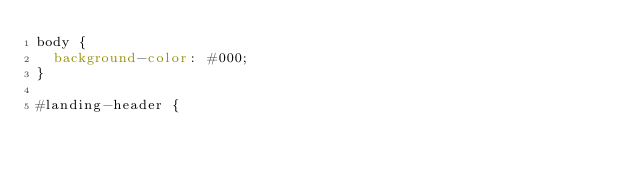<code> <loc_0><loc_0><loc_500><loc_500><_CSS_>body {
  background-color: #000;
}

#landing-header {</code> 